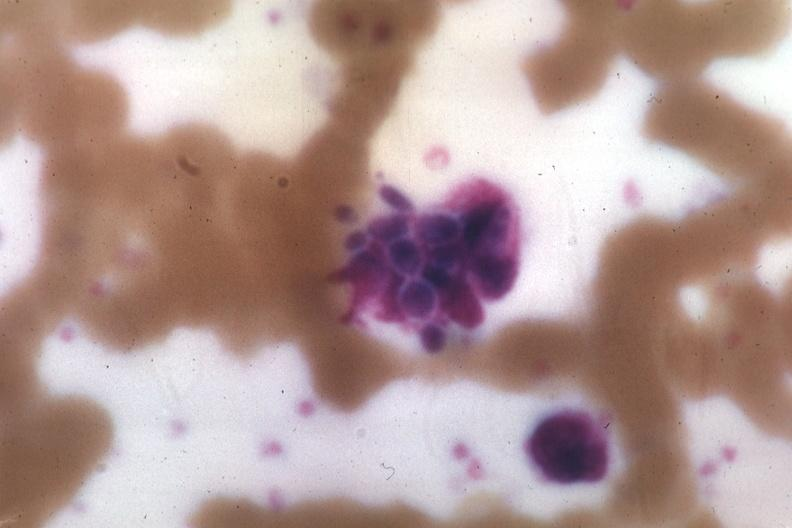s angiogram present?
Answer the question using a single word or phrase. No 